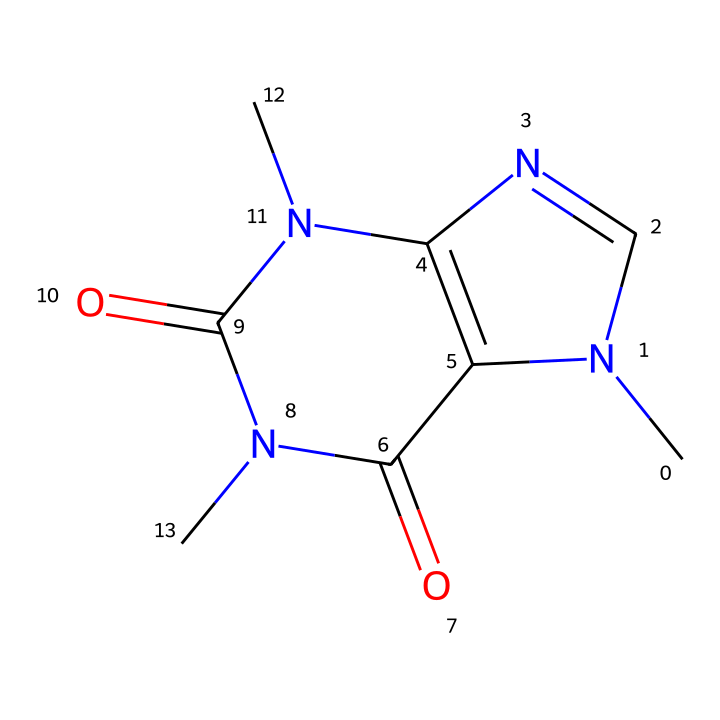What is the molecular formula of caffeine? Analyzing the SMILES representation, I can count the atoms: there are 8 carbons, 10 hydrogens, 4 nitrogens, and 2 oxygens. The molecular formula combines these counts to C8H10N4O2.
Answer: C8H10N4O2 How many nitrogen atoms are in the caffeine structure? By examining the SMILES string, I can identify that there are four nitrogen (N) atoms represented by the letter 'N' in the chemical structure.
Answer: four What type of bonding is primarily found in caffeine? The SMILES representation reveals multiple connections between atoms, particularly the presence of double bonds between carbon and oxygen (C=O) and carbon-nitrogen (C=N), indicating covalent bonding as the primary type of bonding.
Answer: covalent What characteristic does caffeine have due to its nitrogen content? The presence of nitrogen atoms contributes to the basic nature of caffeine, which is typical in many alkaloids, as nitrogen can accept protons, leading to alkaline properties.
Answer: alkaline What is the role of caffeine in the human body? Caffeine functions primarily as a central nervous system stimulant, promoting wakefulness and alertness by blocking adenosine receptors and increasing neurotransmitter release.
Answer: stimulant What is the significance of the carbonyl groups in caffeine's structure? The two carbonyl groups (C=O) in the structure enhance the molecule’s polar characteristics, potentially affecting its solubility and biological activity, typical for many biologically active compounds.
Answer: polar characteristics 